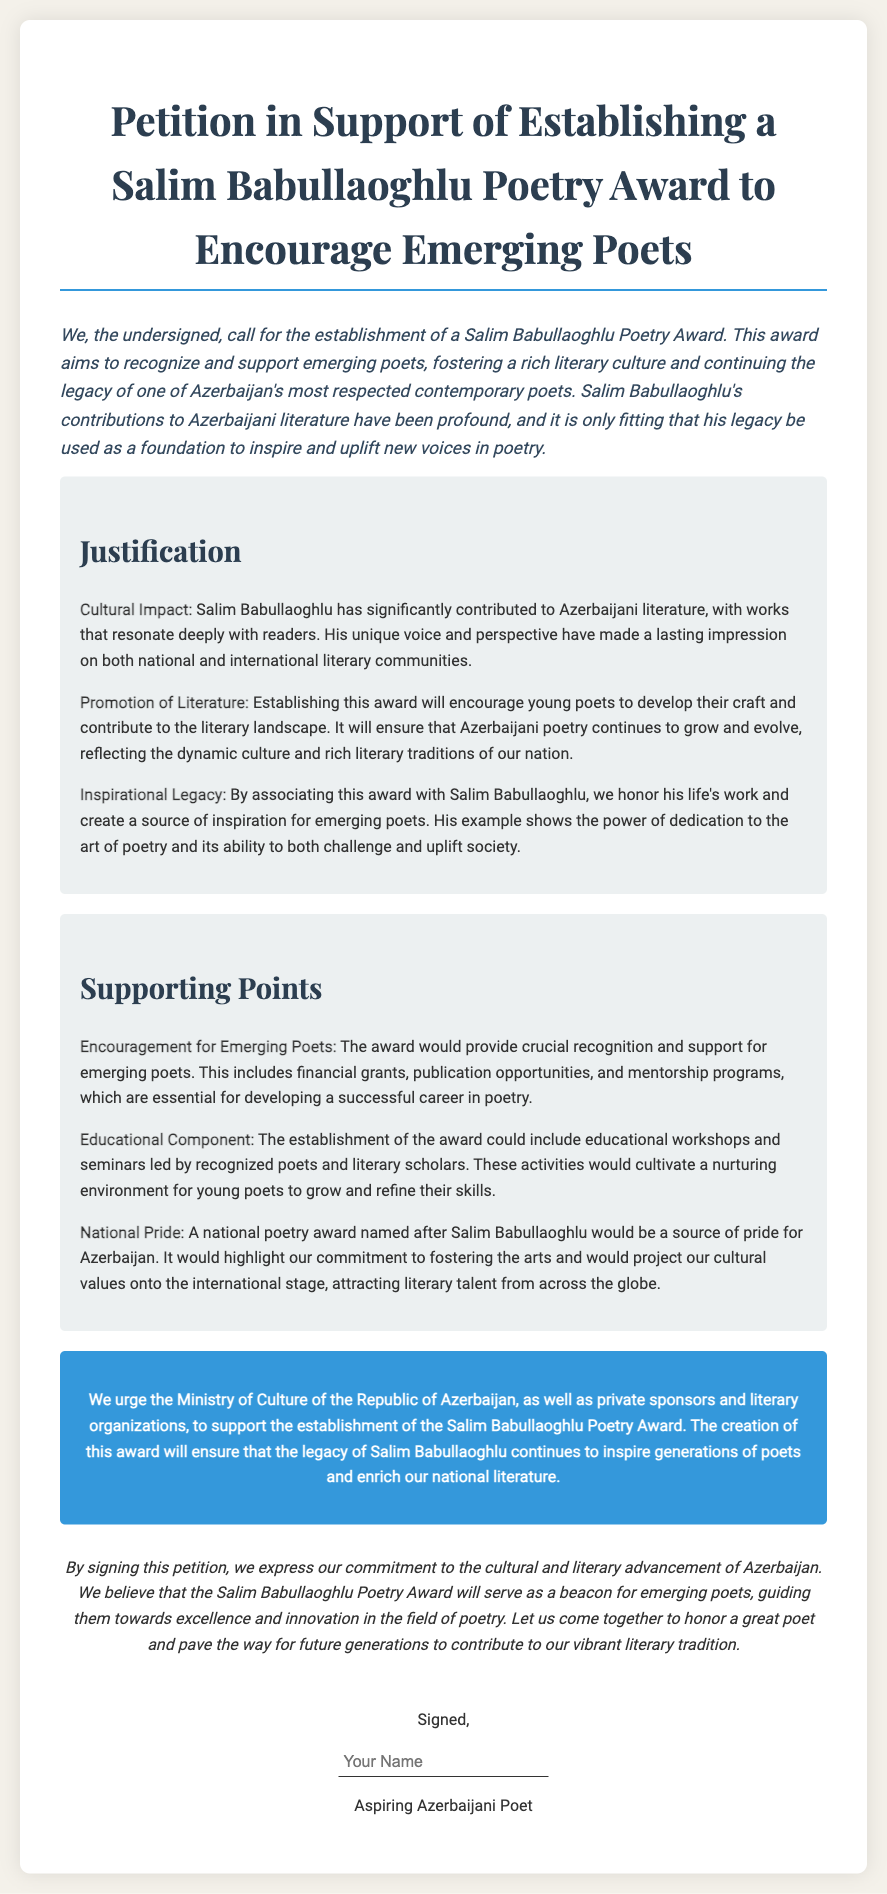What is the title of the petition? The title can be found at the top of the document, outlining the main purpose of the petition.
Answer: Petition in Support of Establishing a Salim Babullaoghlu Poetry Award to Encourage Emerging Poets Who is the petition addressed to? The specific recipient of the petition is mentioned in the call-to-action section.
Answer: Ministry of Culture of the Republic of Azerbaijan What are the key components of support mentioned for emerging poets? The supporting points provide details on what support the award would offer to poets.
Answer: Financial grants, publication opportunities, and mentorship programs What type of activities could be included with the educational component? The educational component section discusses potential activities associated with the award.
Answer: Workshops and seminars What does the petition suggest the award would be a source of for Azerbaijan? This is mentioned in the supporting points, indicating the broader impact of the award.
Answer: National pride Who is noted as the respected figure associated with the award? The document references a prominent poet related to the award's establishment.
Answer: Salim Babullaoghlu How does the petition conclude? The conclusion summarizes the intention and hopes of the petition in a concise manner.
Answer: A beacon for emerging poets What is the required action for individuals who support the petition? The signature section indicates what supporters should do.
Answer: Sign the petition 